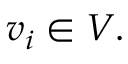<formula> <loc_0><loc_0><loc_500><loc_500>v _ { i } \in V .</formula> 